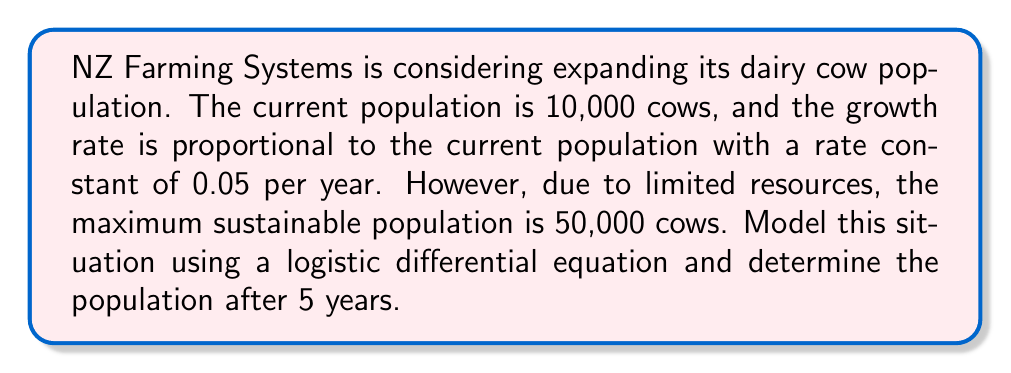Show me your answer to this math problem. Let's approach this step-by-step:

1) The logistic differential equation for population growth is:

   $$\frac{dP}{dt} = rP(1 - \frac{P}{K})$$

   Where:
   - $P$ is the population
   - $t$ is time
   - $r$ is the growth rate constant
   - $K$ is the carrying capacity (maximum sustainable population)

2) In this case:
   - $r = 0.05$ per year
   - $K = 50,000$ cows
   - Initial population $P_0 = 10,000$ cows

3) The solution to the logistic differential equation is:

   $$P(t) = \frac{KP_0e^{rt}}{K + P_0(e^{rt} - 1)}$$

4) Substituting our values:

   $$P(t) = \frac{50000 \cdot 10000e^{0.05t}}{50000 + 10000(e^{0.05t} - 1)}$$

5) We want to find $P(5)$, so let's substitute $t = 5$:

   $$P(5) = \frac{50000 \cdot 10000e^{0.05 \cdot 5}}{50000 + 10000(e^{0.05 \cdot 5} - 1)}$$

6) Calculate $e^{0.05 \cdot 5} = e^{0.25} \approx 1.2840$

7) Substituting this value:

   $$P(5) = \frac{50000 \cdot 10000 \cdot 1.2840}{50000 + 10000(1.2840 - 1)}$$

8) Simplify:

   $$P(5) = \frac{642000000}{50000 + 2840} \approx 12,186$$

Therefore, after 5 years, the population will be approximately 12,186 cows.
Answer: After 5 years, the dairy cow population will be approximately 12,186 cows. 